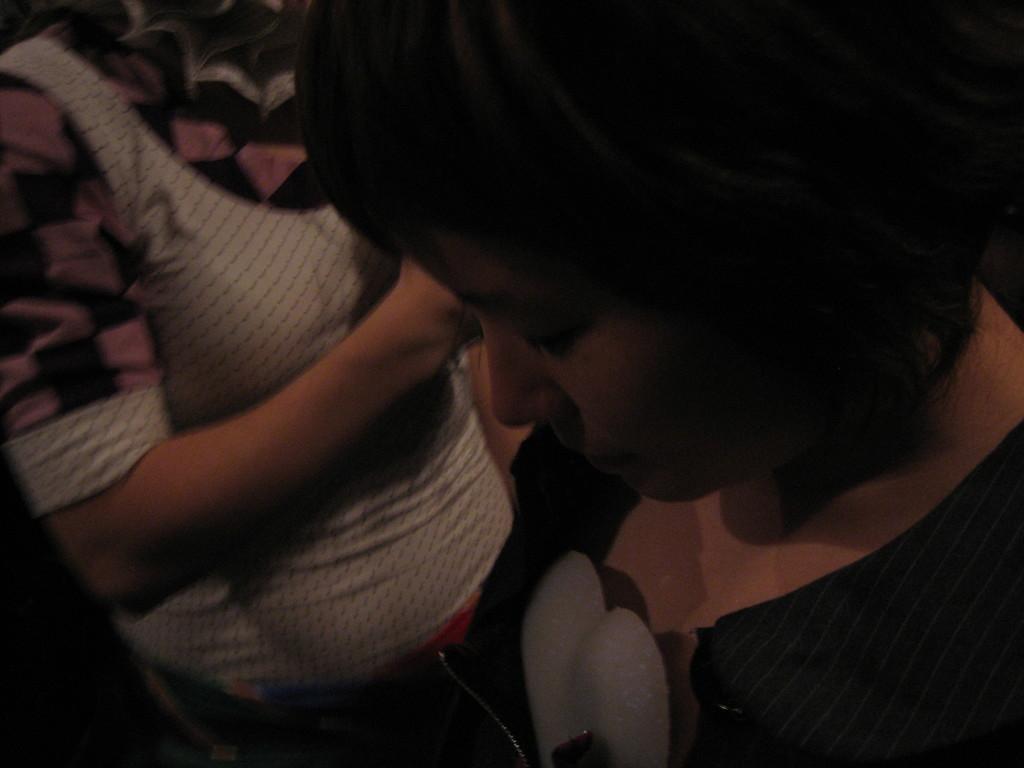Please provide a concise description of this image. In this image in the foreground there is one woman, and in the background there is another person who is standing. 